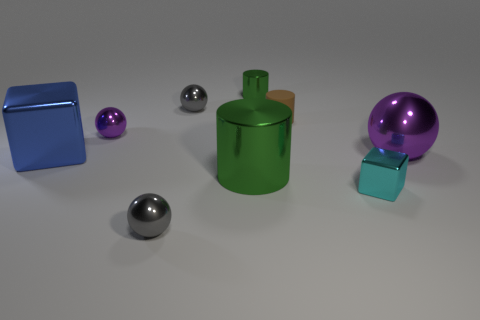Add 1 small purple metal blocks. How many objects exist? 10 Subtract all spheres. How many objects are left? 5 Add 5 tiny rubber things. How many tiny rubber things are left? 6 Add 3 large metallic balls. How many large metallic balls exist? 4 Subtract 0 brown cubes. How many objects are left? 9 Subtract all small green things. Subtract all blocks. How many objects are left? 6 